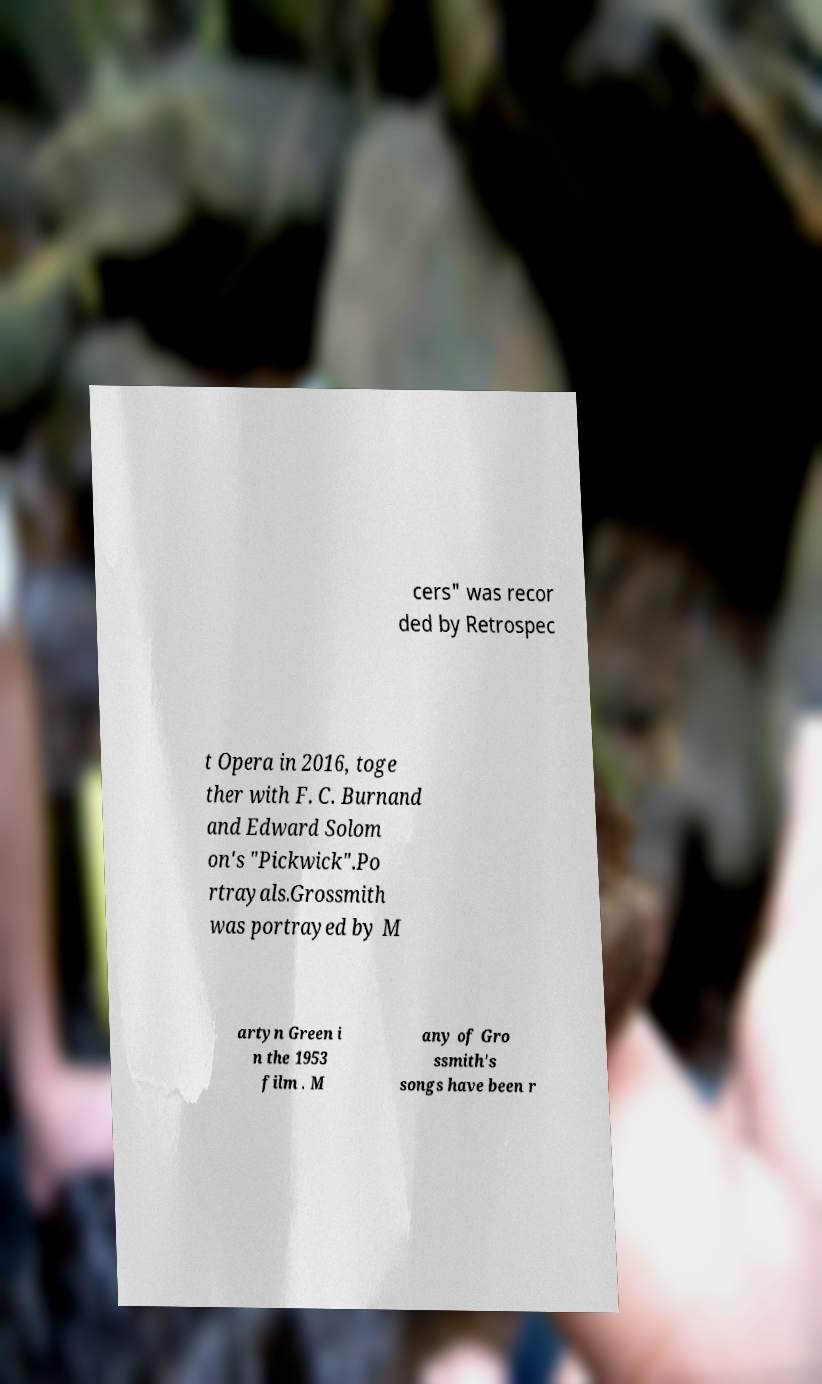Can you accurately transcribe the text from the provided image for me? cers" was recor ded by Retrospec t Opera in 2016, toge ther with F. C. Burnand and Edward Solom on's "Pickwick".Po rtrayals.Grossmith was portrayed by M artyn Green i n the 1953 film . M any of Gro ssmith's songs have been r 